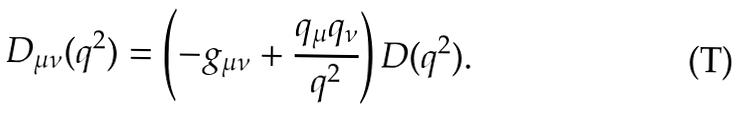<formula> <loc_0><loc_0><loc_500><loc_500>D _ { \mu \nu } ( q ^ { 2 } ) = \left ( - g _ { \mu \nu } + \frac { q _ { \mu } q _ { \nu } } { q ^ { 2 } } \right ) D ( q ^ { 2 } ) .</formula> 